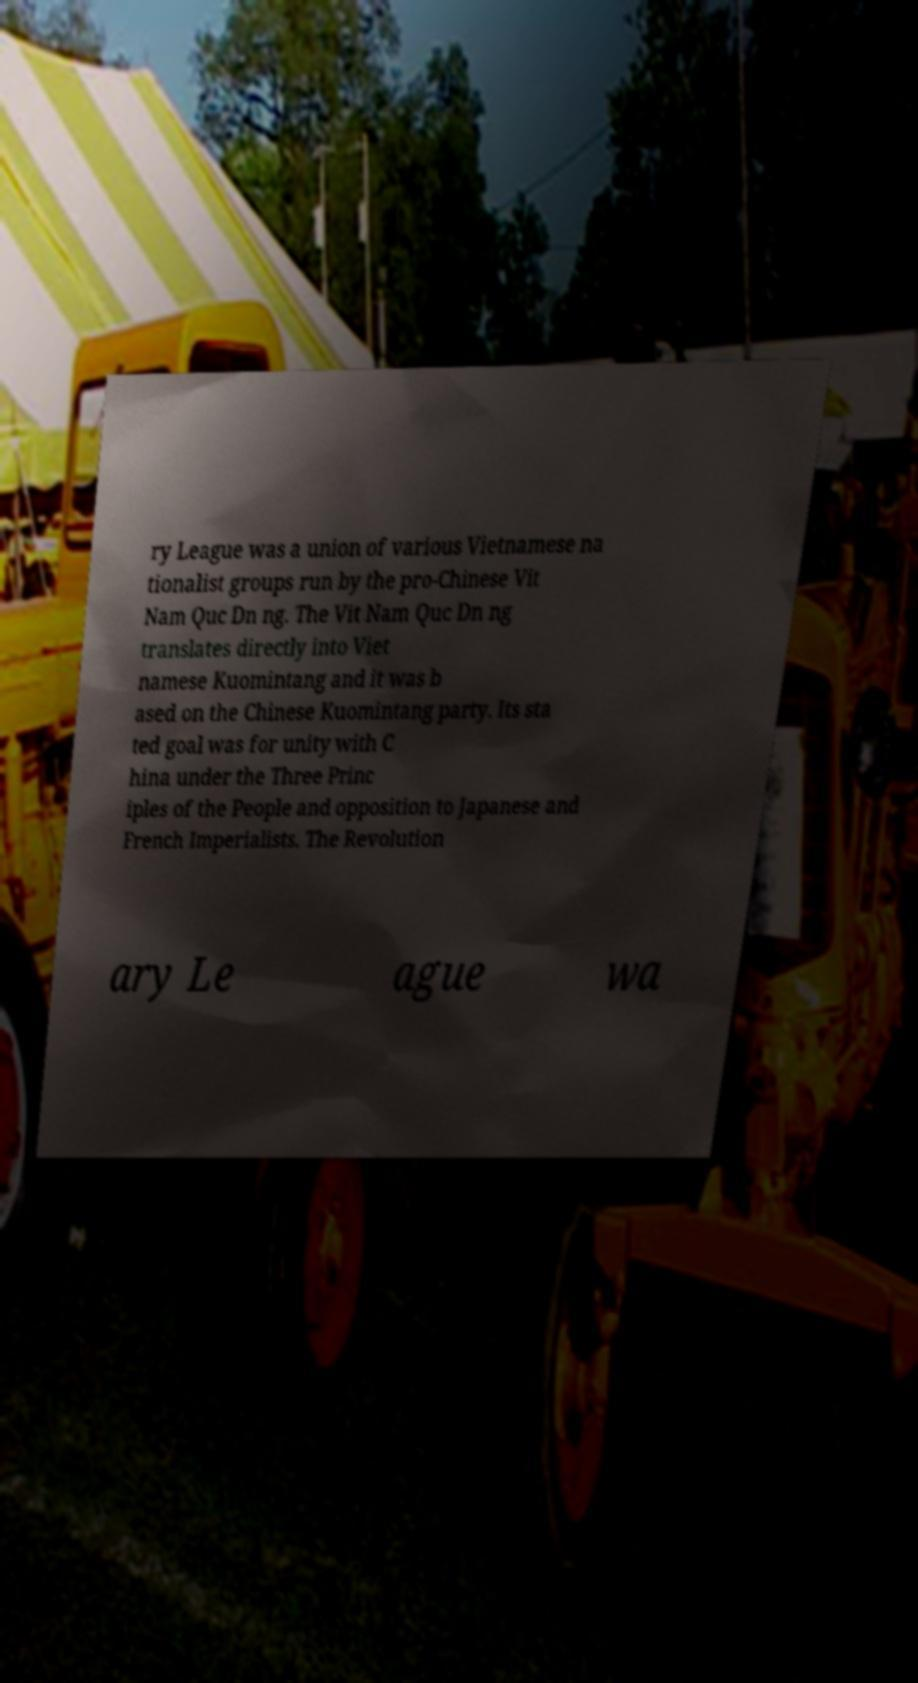Could you extract and type out the text from this image? ry League was a union of various Vietnamese na tionalist groups run by the pro-Chinese Vit Nam Quc Dn ng. The Vit Nam Quc Dn ng translates directly into Viet namese Kuomintang and it was b ased on the Chinese Kuomintang party. Its sta ted goal was for unity with C hina under the Three Princ iples of the People and opposition to Japanese and French Imperialists. The Revolution ary Le ague wa 